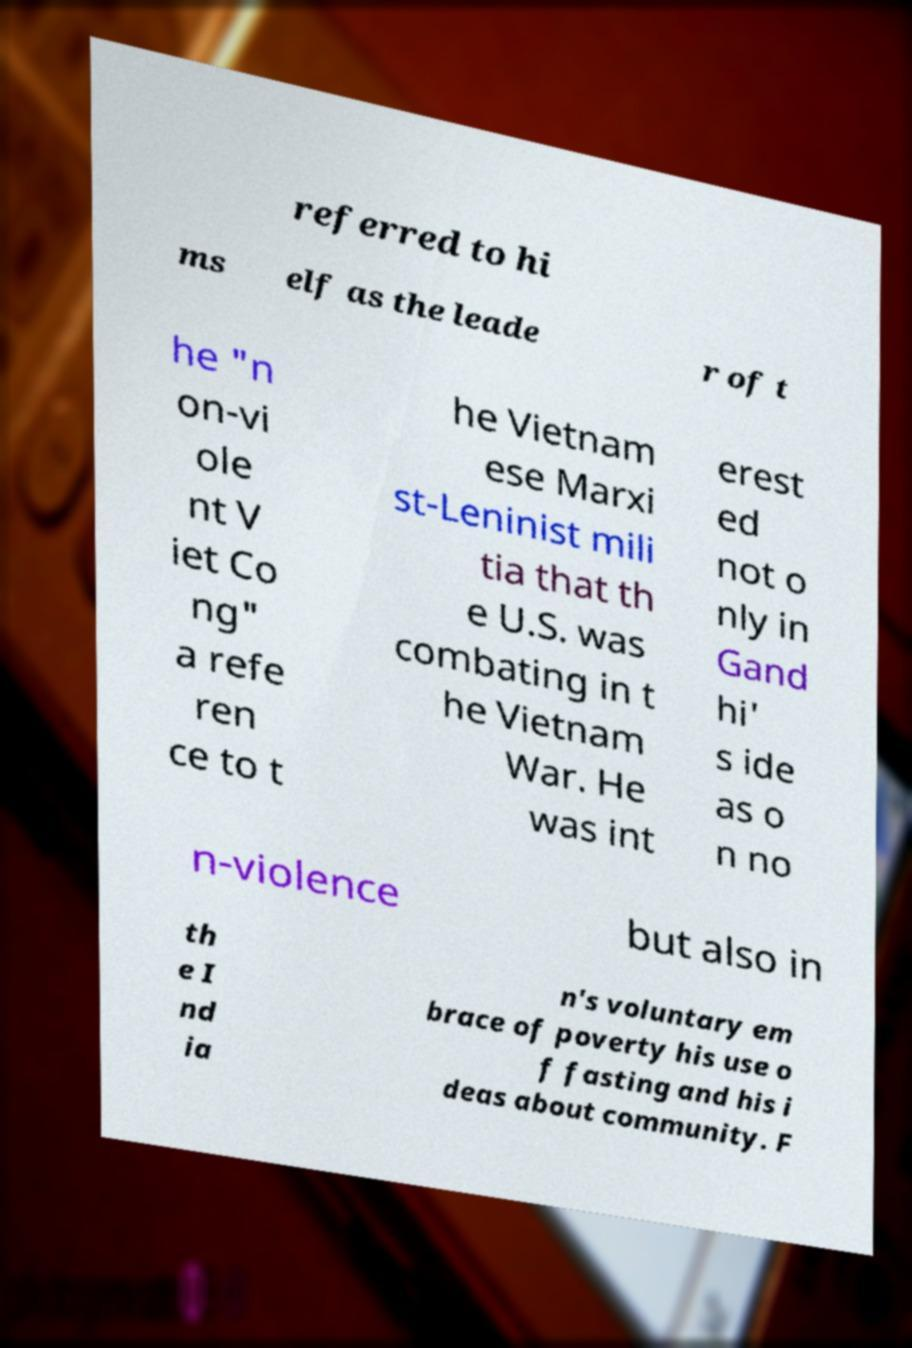For documentation purposes, I need the text within this image transcribed. Could you provide that? referred to hi ms elf as the leade r of t he "n on-vi ole nt V iet Co ng" a refe ren ce to t he Vietnam ese Marxi st-Leninist mili tia that th e U.S. was combating in t he Vietnam War. He was int erest ed not o nly in Gand hi' s ide as o n no n-violence but also in th e I nd ia n's voluntary em brace of poverty his use o f fasting and his i deas about community. F 